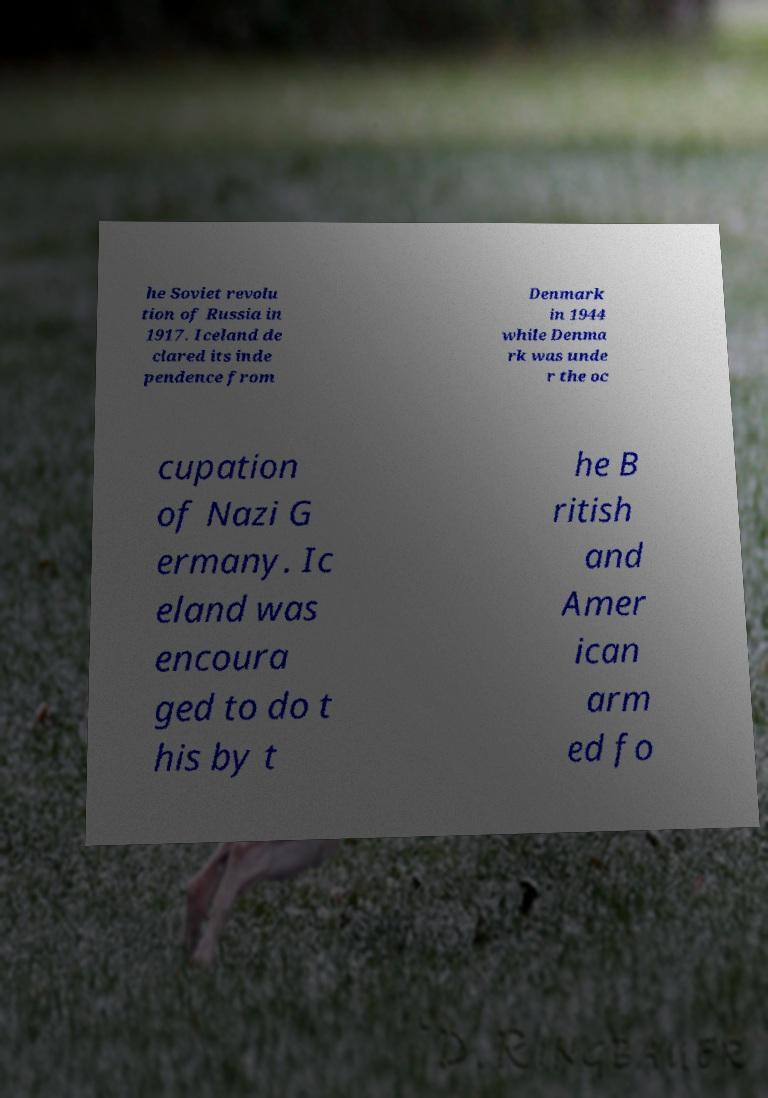There's text embedded in this image that I need extracted. Can you transcribe it verbatim? he Soviet revolu tion of Russia in 1917. Iceland de clared its inde pendence from Denmark in 1944 while Denma rk was unde r the oc cupation of Nazi G ermany. Ic eland was encoura ged to do t his by t he B ritish and Amer ican arm ed fo 